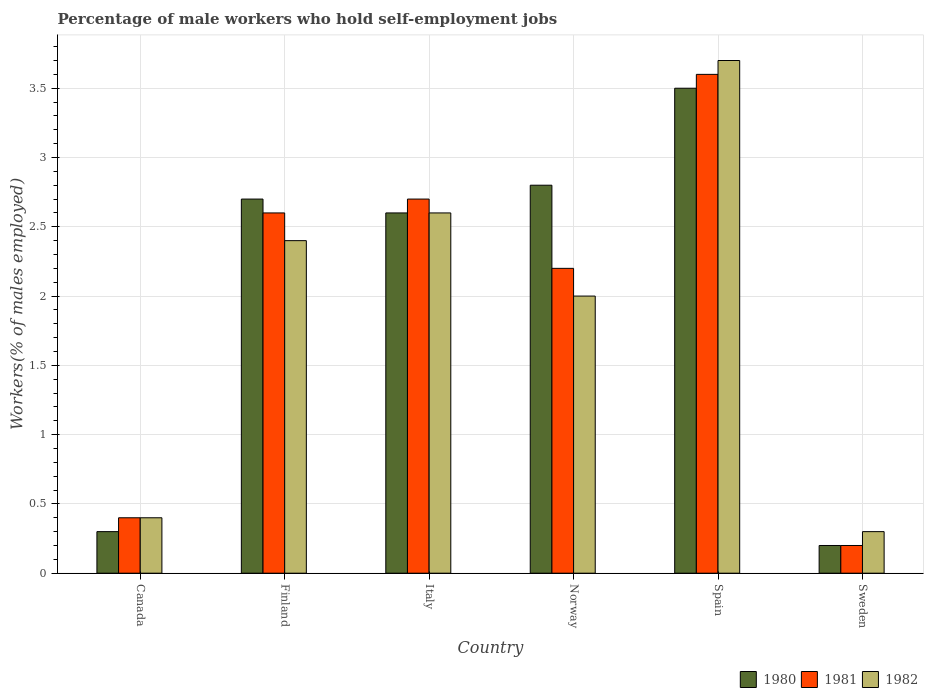How many groups of bars are there?
Your answer should be compact. 6. Are the number of bars on each tick of the X-axis equal?
Your answer should be very brief. Yes. How many bars are there on the 3rd tick from the left?
Offer a terse response. 3. How many bars are there on the 1st tick from the right?
Provide a succinct answer. 3. What is the label of the 4th group of bars from the left?
Your answer should be compact. Norway. What is the percentage of self-employed male workers in 1982 in Norway?
Offer a very short reply. 2. Across all countries, what is the minimum percentage of self-employed male workers in 1981?
Ensure brevity in your answer.  0.2. In which country was the percentage of self-employed male workers in 1980 minimum?
Offer a very short reply. Sweden. What is the total percentage of self-employed male workers in 1980 in the graph?
Keep it short and to the point. 12.1. What is the difference between the percentage of self-employed male workers in 1982 in Finland and that in Spain?
Offer a terse response. -1.3. What is the difference between the percentage of self-employed male workers in 1980 in Norway and the percentage of self-employed male workers in 1982 in Spain?
Offer a terse response. -0.9. What is the average percentage of self-employed male workers in 1980 per country?
Your answer should be very brief. 2.02. What is the difference between the percentage of self-employed male workers of/in 1981 and percentage of self-employed male workers of/in 1982 in Spain?
Ensure brevity in your answer.  -0.1. What is the ratio of the percentage of self-employed male workers in 1982 in Canada to that in Finland?
Provide a succinct answer. 0.17. Is the difference between the percentage of self-employed male workers in 1981 in Italy and Spain greater than the difference between the percentage of self-employed male workers in 1982 in Italy and Spain?
Your response must be concise. Yes. What is the difference between the highest and the second highest percentage of self-employed male workers in 1981?
Offer a terse response. -0.9. What is the difference between the highest and the lowest percentage of self-employed male workers in 1981?
Offer a very short reply. 3.4. In how many countries, is the percentage of self-employed male workers in 1982 greater than the average percentage of self-employed male workers in 1982 taken over all countries?
Ensure brevity in your answer.  4. Is it the case that in every country, the sum of the percentage of self-employed male workers in 1981 and percentage of self-employed male workers in 1980 is greater than the percentage of self-employed male workers in 1982?
Give a very brief answer. Yes. How many bars are there?
Offer a terse response. 18. What is the difference between two consecutive major ticks on the Y-axis?
Your answer should be very brief. 0.5. Does the graph contain any zero values?
Make the answer very short. No. Does the graph contain grids?
Make the answer very short. Yes. Where does the legend appear in the graph?
Offer a very short reply. Bottom right. How are the legend labels stacked?
Your response must be concise. Horizontal. What is the title of the graph?
Make the answer very short. Percentage of male workers who hold self-employment jobs. Does "1993" appear as one of the legend labels in the graph?
Your answer should be compact. No. What is the label or title of the Y-axis?
Offer a very short reply. Workers(% of males employed). What is the Workers(% of males employed) of 1980 in Canada?
Offer a very short reply. 0.3. What is the Workers(% of males employed) in 1981 in Canada?
Your answer should be very brief. 0.4. What is the Workers(% of males employed) of 1982 in Canada?
Offer a very short reply. 0.4. What is the Workers(% of males employed) of 1980 in Finland?
Give a very brief answer. 2.7. What is the Workers(% of males employed) in 1981 in Finland?
Provide a short and direct response. 2.6. What is the Workers(% of males employed) of 1982 in Finland?
Your response must be concise. 2.4. What is the Workers(% of males employed) in 1980 in Italy?
Offer a terse response. 2.6. What is the Workers(% of males employed) in 1981 in Italy?
Keep it short and to the point. 2.7. What is the Workers(% of males employed) of 1982 in Italy?
Make the answer very short. 2.6. What is the Workers(% of males employed) of 1980 in Norway?
Provide a succinct answer. 2.8. What is the Workers(% of males employed) in 1981 in Norway?
Give a very brief answer. 2.2. What is the Workers(% of males employed) in 1981 in Spain?
Ensure brevity in your answer.  3.6. What is the Workers(% of males employed) in 1982 in Spain?
Provide a succinct answer. 3.7. What is the Workers(% of males employed) in 1980 in Sweden?
Your response must be concise. 0.2. What is the Workers(% of males employed) in 1981 in Sweden?
Provide a short and direct response. 0.2. What is the Workers(% of males employed) of 1982 in Sweden?
Make the answer very short. 0.3. Across all countries, what is the maximum Workers(% of males employed) in 1981?
Your response must be concise. 3.6. Across all countries, what is the maximum Workers(% of males employed) of 1982?
Your answer should be compact. 3.7. Across all countries, what is the minimum Workers(% of males employed) of 1980?
Your answer should be compact. 0.2. Across all countries, what is the minimum Workers(% of males employed) in 1981?
Keep it short and to the point. 0.2. Across all countries, what is the minimum Workers(% of males employed) in 1982?
Your response must be concise. 0.3. What is the total Workers(% of males employed) of 1981 in the graph?
Your response must be concise. 11.7. What is the total Workers(% of males employed) of 1982 in the graph?
Keep it short and to the point. 11.4. What is the difference between the Workers(% of males employed) in 1980 in Canada and that in Finland?
Give a very brief answer. -2.4. What is the difference between the Workers(% of males employed) in 1981 in Canada and that in Finland?
Your response must be concise. -2.2. What is the difference between the Workers(% of males employed) of 1982 in Canada and that in Finland?
Offer a very short reply. -2. What is the difference between the Workers(% of males employed) of 1982 in Canada and that in Italy?
Keep it short and to the point. -2.2. What is the difference between the Workers(% of males employed) in 1982 in Canada and that in Norway?
Make the answer very short. -1.6. What is the difference between the Workers(% of males employed) of 1982 in Canada and that in Spain?
Provide a short and direct response. -3.3. What is the difference between the Workers(% of males employed) in 1981 in Finland and that in Italy?
Keep it short and to the point. -0.1. What is the difference between the Workers(% of males employed) in 1982 in Finland and that in Italy?
Ensure brevity in your answer.  -0.2. What is the difference between the Workers(% of males employed) of 1980 in Finland and that in Norway?
Offer a very short reply. -0.1. What is the difference between the Workers(% of males employed) in 1981 in Finland and that in Norway?
Keep it short and to the point. 0.4. What is the difference between the Workers(% of males employed) in 1981 in Finland and that in Spain?
Provide a short and direct response. -1. What is the difference between the Workers(% of males employed) of 1981 in Finland and that in Sweden?
Your answer should be very brief. 2.4. What is the difference between the Workers(% of males employed) of 1980 in Italy and that in Sweden?
Your answer should be very brief. 2.4. What is the difference between the Workers(% of males employed) in 1981 in Italy and that in Sweden?
Give a very brief answer. 2.5. What is the difference between the Workers(% of males employed) in 1982 in Italy and that in Sweden?
Give a very brief answer. 2.3. What is the difference between the Workers(% of males employed) in 1980 in Norway and that in Spain?
Make the answer very short. -0.7. What is the difference between the Workers(% of males employed) of 1981 in Norway and that in Sweden?
Your answer should be compact. 2. What is the difference between the Workers(% of males employed) in 1980 in Spain and that in Sweden?
Provide a succinct answer. 3.3. What is the difference between the Workers(% of males employed) of 1981 in Spain and that in Sweden?
Your answer should be compact. 3.4. What is the difference between the Workers(% of males employed) in 1981 in Canada and the Workers(% of males employed) in 1982 in Italy?
Give a very brief answer. -2.2. What is the difference between the Workers(% of males employed) of 1980 in Canada and the Workers(% of males employed) of 1981 in Norway?
Offer a very short reply. -1.9. What is the difference between the Workers(% of males employed) in 1980 in Canada and the Workers(% of males employed) in 1982 in Norway?
Your answer should be very brief. -1.7. What is the difference between the Workers(% of males employed) of 1981 in Canada and the Workers(% of males employed) of 1982 in Norway?
Keep it short and to the point. -1.6. What is the difference between the Workers(% of males employed) in 1980 in Canada and the Workers(% of males employed) in 1982 in Spain?
Your answer should be compact. -3.4. What is the difference between the Workers(% of males employed) in 1981 in Canada and the Workers(% of males employed) in 1982 in Spain?
Make the answer very short. -3.3. What is the difference between the Workers(% of males employed) in 1980 in Canada and the Workers(% of males employed) in 1981 in Sweden?
Ensure brevity in your answer.  0.1. What is the difference between the Workers(% of males employed) in 1980 in Canada and the Workers(% of males employed) in 1982 in Sweden?
Make the answer very short. 0. What is the difference between the Workers(% of males employed) of 1980 in Finland and the Workers(% of males employed) of 1981 in Italy?
Offer a terse response. 0. What is the difference between the Workers(% of males employed) in 1981 in Finland and the Workers(% of males employed) in 1982 in Italy?
Your answer should be compact. 0. What is the difference between the Workers(% of males employed) of 1980 in Finland and the Workers(% of males employed) of 1981 in Sweden?
Provide a short and direct response. 2.5. What is the difference between the Workers(% of males employed) in 1980 in Finland and the Workers(% of males employed) in 1982 in Sweden?
Keep it short and to the point. 2.4. What is the difference between the Workers(% of males employed) in 1980 in Italy and the Workers(% of males employed) in 1982 in Norway?
Provide a succinct answer. 0.6. What is the difference between the Workers(% of males employed) of 1980 in Italy and the Workers(% of males employed) of 1981 in Spain?
Your answer should be compact. -1. What is the difference between the Workers(% of males employed) of 1980 in Italy and the Workers(% of males employed) of 1982 in Spain?
Provide a short and direct response. -1.1. What is the difference between the Workers(% of males employed) of 1981 in Italy and the Workers(% of males employed) of 1982 in Spain?
Ensure brevity in your answer.  -1. What is the difference between the Workers(% of males employed) of 1980 in Italy and the Workers(% of males employed) of 1981 in Sweden?
Provide a short and direct response. 2.4. What is the difference between the Workers(% of males employed) in 1980 in Italy and the Workers(% of males employed) in 1982 in Sweden?
Provide a short and direct response. 2.3. What is the difference between the Workers(% of males employed) in 1980 in Norway and the Workers(% of males employed) in 1981 in Spain?
Provide a succinct answer. -0.8. What is the difference between the Workers(% of males employed) in 1980 in Norway and the Workers(% of males employed) in 1982 in Spain?
Offer a very short reply. -0.9. What is the difference between the Workers(% of males employed) of 1981 in Norway and the Workers(% of males employed) of 1982 in Spain?
Provide a short and direct response. -1.5. What is the difference between the Workers(% of males employed) of 1980 in Norway and the Workers(% of males employed) of 1981 in Sweden?
Offer a terse response. 2.6. What is the difference between the Workers(% of males employed) of 1981 in Norway and the Workers(% of males employed) of 1982 in Sweden?
Offer a terse response. 1.9. What is the difference between the Workers(% of males employed) in 1980 in Spain and the Workers(% of males employed) in 1981 in Sweden?
Give a very brief answer. 3.3. What is the difference between the Workers(% of males employed) in 1981 in Spain and the Workers(% of males employed) in 1982 in Sweden?
Keep it short and to the point. 3.3. What is the average Workers(% of males employed) in 1980 per country?
Your response must be concise. 2.02. What is the average Workers(% of males employed) of 1981 per country?
Your answer should be compact. 1.95. What is the difference between the Workers(% of males employed) in 1980 and Workers(% of males employed) in 1981 in Canada?
Give a very brief answer. -0.1. What is the difference between the Workers(% of males employed) of 1980 and Workers(% of males employed) of 1982 in Finland?
Ensure brevity in your answer.  0.3. What is the difference between the Workers(% of males employed) in 1980 and Workers(% of males employed) in 1982 in Italy?
Give a very brief answer. 0. What is the difference between the Workers(% of males employed) of 1981 and Workers(% of males employed) of 1982 in Italy?
Keep it short and to the point. 0.1. What is the difference between the Workers(% of males employed) in 1981 and Workers(% of males employed) in 1982 in Norway?
Offer a terse response. 0.2. What is the difference between the Workers(% of males employed) of 1980 and Workers(% of males employed) of 1981 in Spain?
Keep it short and to the point. -0.1. What is the difference between the Workers(% of males employed) in 1980 and Workers(% of males employed) in 1982 in Spain?
Offer a terse response. -0.2. What is the difference between the Workers(% of males employed) in 1980 and Workers(% of males employed) in 1981 in Sweden?
Offer a very short reply. 0. What is the difference between the Workers(% of males employed) of 1981 and Workers(% of males employed) of 1982 in Sweden?
Provide a short and direct response. -0.1. What is the ratio of the Workers(% of males employed) in 1980 in Canada to that in Finland?
Give a very brief answer. 0.11. What is the ratio of the Workers(% of males employed) in 1981 in Canada to that in Finland?
Keep it short and to the point. 0.15. What is the ratio of the Workers(% of males employed) of 1982 in Canada to that in Finland?
Give a very brief answer. 0.17. What is the ratio of the Workers(% of males employed) of 1980 in Canada to that in Italy?
Your answer should be very brief. 0.12. What is the ratio of the Workers(% of males employed) of 1981 in Canada to that in Italy?
Provide a short and direct response. 0.15. What is the ratio of the Workers(% of males employed) of 1982 in Canada to that in Italy?
Give a very brief answer. 0.15. What is the ratio of the Workers(% of males employed) of 1980 in Canada to that in Norway?
Offer a very short reply. 0.11. What is the ratio of the Workers(% of males employed) of 1981 in Canada to that in Norway?
Your response must be concise. 0.18. What is the ratio of the Workers(% of males employed) of 1980 in Canada to that in Spain?
Provide a succinct answer. 0.09. What is the ratio of the Workers(% of males employed) of 1981 in Canada to that in Spain?
Your response must be concise. 0.11. What is the ratio of the Workers(% of males employed) of 1982 in Canada to that in Spain?
Your answer should be very brief. 0.11. What is the ratio of the Workers(% of males employed) of 1982 in Canada to that in Sweden?
Provide a short and direct response. 1.33. What is the ratio of the Workers(% of males employed) in 1980 in Finland to that in Italy?
Provide a short and direct response. 1.04. What is the ratio of the Workers(% of males employed) in 1980 in Finland to that in Norway?
Provide a succinct answer. 0.96. What is the ratio of the Workers(% of males employed) in 1981 in Finland to that in Norway?
Ensure brevity in your answer.  1.18. What is the ratio of the Workers(% of males employed) in 1982 in Finland to that in Norway?
Give a very brief answer. 1.2. What is the ratio of the Workers(% of males employed) in 1980 in Finland to that in Spain?
Provide a succinct answer. 0.77. What is the ratio of the Workers(% of males employed) of 1981 in Finland to that in Spain?
Your response must be concise. 0.72. What is the ratio of the Workers(% of males employed) in 1982 in Finland to that in Spain?
Your answer should be compact. 0.65. What is the ratio of the Workers(% of males employed) in 1981 in Finland to that in Sweden?
Offer a very short reply. 13. What is the ratio of the Workers(% of males employed) in 1980 in Italy to that in Norway?
Your response must be concise. 0.93. What is the ratio of the Workers(% of males employed) of 1981 in Italy to that in Norway?
Give a very brief answer. 1.23. What is the ratio of the Workers(% of males employed) of 1982 in Italy to that in Norway?
Provide a succinct answer. 1.3. What is the ratio of the Workers(% of males employed) of 1980 in Italy to that in Spain?
Offer a terse response. 0.74. What is the ratio of the Workers(% of males employed) of 1981 in Italy to that in Spain?
Provide a short and direct response. 0.75. What is the ratio of the Workers(% of males employed) of 1982 in Italy to that in Spain?
Provide a short and direct response. 0.7. What is the ratio of the Workers(% of males employed) of 1982 in Italy to that in Sweden?
Offer a very short reply. 8.67. What is the ratio of the Workers(% of males employed) in 1980 in Norway to that in Spain?
Your answer should be compact. 0.8. What is the ratio of the Workers(% of males employed) in 1981 in Norway to that in Spain?
Your answer should be compact. 0.61. What is the ratio of the Workers(% of males employed) in 1982 in Norway to that in Spain?
Your answer should be very brief. 0.54. What is the ratio of the Workers(% of males employed) in 1980 in Norway to that in Sweden?
Provide a succinct answer. 14. What is the ratio of the Workers(% of males employed) of 1982 in Norway to that in Sweden?
Ensure brevity in your answer.  6.67. What is the ratio of the Workers(% of males employed) in 1980 in Spain to that in Sweden?
Offer a very short reply. 17.5. What is the ratio of the Workers(% of males employed) in 1982 in Spain to that in Sweden?
Offer a terse response. 12.33. What is the difference between the highest and the second highest Workers(% of males employed) in 1980?
Provide a succinct answer. 0.7. What is the difference between the highest and the second highest Workers(% of males employed) in 1982?
Make the answer very short. 1.1. What is the difference between the highest and the lowest Workers(% of males employed) of 1980?
Offer a terse response. 3.3. 